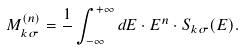Convert formula to latex. <formula><loc_0><loc_0><loc_500><loc_500>M _ { k \sigma } ^ { ( n ) } = \frac { 1 } { } \int _ { - \infty } ^ { + \infty } d E \cdot E ^ { n } \cdot S _ { k \sigma } ( E ) .</formula> 